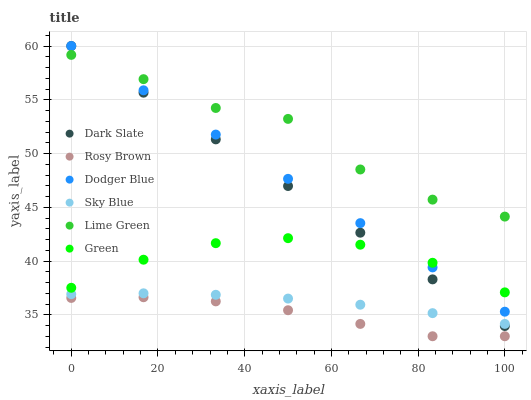Does Rosy Brown have the minimum area under the curve?
Answer yes or no. Yes. Does Lime Green have the maximum area under the curve?
Answer yes or no. Yes. Does Dark Slate have the minimum area under the curve?
Answer yes or no. No. Does Dark Slate have the maximum area under the curve?
Answer yes or no. No. Is Dark Slate the smoothest?
Answer yes or no. Yes. Is Lime Green the roughest?
Answer yes or no. Yes. Is Dodger Blue the smoothest?
Answer yes or no. No. Is Dodger Blue the roughest?
Answer yes or no. No. Does Rosy Brown have the lowest value?
Answer yes or no. Yes. Does Dark Slate have the lowest value?
Answer yes or no. No. Does Dodger Blue have the highest value?
Answer yes or no. Yes. Does Sky Blue have the highest value?
Answer yes or no. No. Is Rosy Brown less than Sky Blue?
Answer yes or no. Yes. Is Green greater than Rosy Brown?
Answer yes or no. Yes. Does Dark Slate intersect Dodger Blue?
Answer yes or no. Yes. Is Dark Slate less than Dodger Blue?
Answer yes or no. No. Is Dark Slate greater than Dodger Blue?
Answer yes or no. No. Does Rosy Brown intersect Sky Blue?
Answer yes or no. No. 